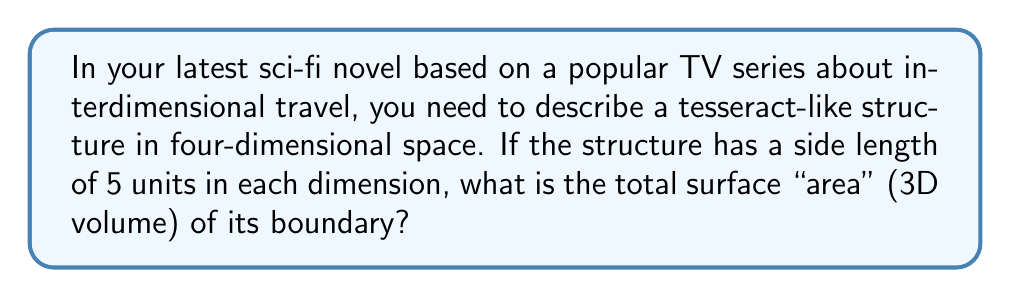Solve this math problem. Let's approach this step-by-step:

1) A tesseract is a 4D analogue of a cube. Just as a cube has 6 square faces, a tesseract has 8 cubic cells.

2) Each cell is a 3D cube with side length 5 units. We need to calculate the volume of each cell and then multiply by the number of cells.

3) The volume of a cube is given by the formula:
   $$V = s^3$$
   where $s$ is the side length.

4) Substituting our side length:
   $$V = 5^3 = 125$$ cubic units

5) Since there are 8 cells in a tesseract, we multiply this by 8:
   $$\text{Total surface "area"} = 8 * 125 = 1000$$ cubic units

6) This result represents the 3D volume of the boundary of the 4D tesseract, which is analogous to the 2D surface area of a 3D cube.

[asy]
import three;

size(200);
currentprojection=perspective(6,3,2);

draw(unitcube,blue);
draw(shift(2,2,2)*unitcube,blue);
draw((0,0,0)--(2,2,2),blue);
draw((1,0,0)--(3,2,2),blue);
draw((0,1,0)--(2,3,2),blue);
draw((0,0,1)--(2,2,3),blue);
draw((1,1,0)--(3,3,2),blue);
draw((1,0,1)--(3,2,3),blue);
draw((0,1,1)--(2,3,3),blue);
draw((1,1,1)--(3,3,3),blue);

label("4D", (1,1,1), Z);
[/asy]
Answer: 1000 cubic units 